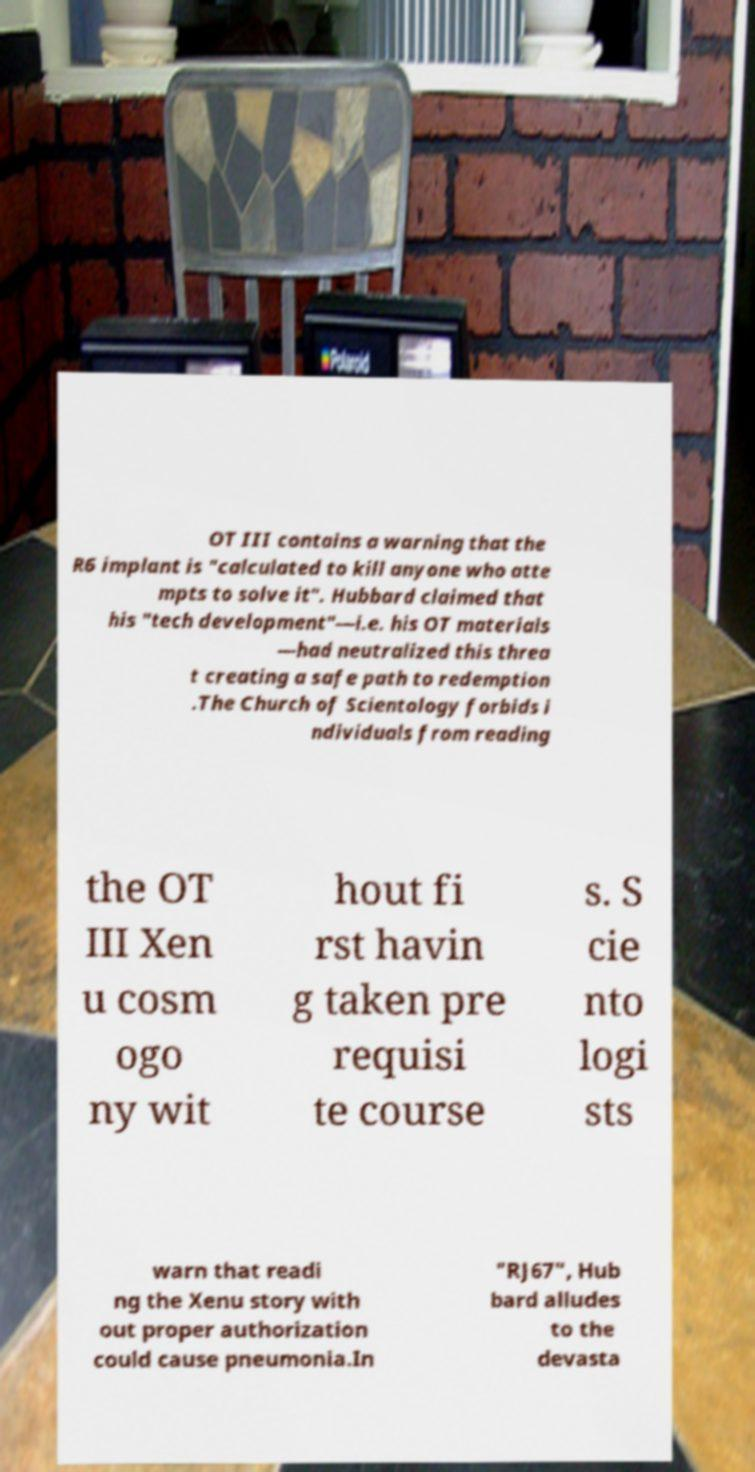Please identify and transcribe the text found in this image. OT III contains a warning that the R6 implant is "calculated to kill anyone who atte mpts to solve it". Hubbard claimed that his "tech development"—i.e. his OT materials —had neutralized this threa t creating a safe path to redemption .The Church of Scientology forbids i ndividuals from reading the OT III Xen u cosm ogo ny wit hout fi rst havin g taken pre requisi te course s. S cie nto logi sts warn that readi ng the Xenu story with out proper authorization could cause pneumonia.In "RJ67", Hub bard alludes to the devasta 